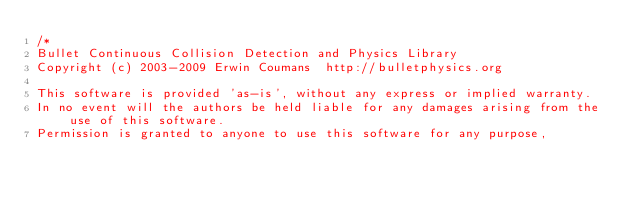Convert code to text. <code><loc_0><loc_0><loc_500><loc_500><_C++_>/*
Bullet Continuous Collision Detection and Physics Library
Copyright (c) 2003-2009 Erwin Coumans  http://bulletphysics.org

This software is provided 'as-is', without any express or implied warranty.
In no event will the authors be held liable for any damages arising from the use of this software.
Permission is granted to anyone to use this software for any purpose,</code> 